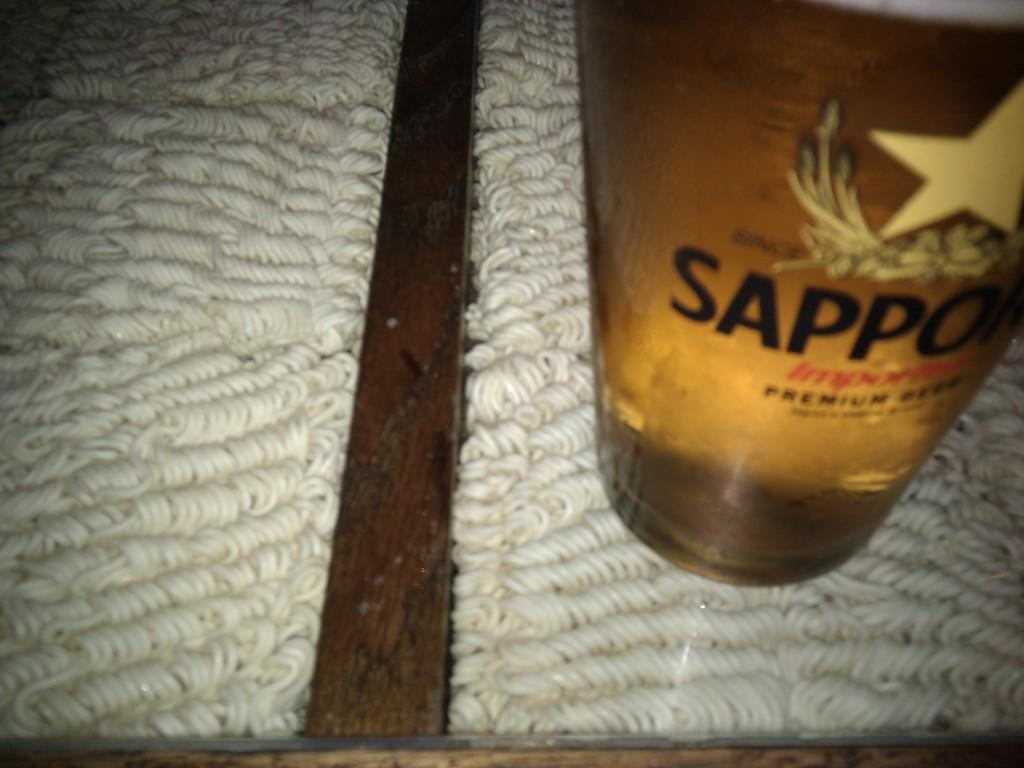<image>
Provide a brief description of the given image. A bottle has a star and has the word Sappo on it, although there might be more to the word Sappo as it is partially obscurred. 